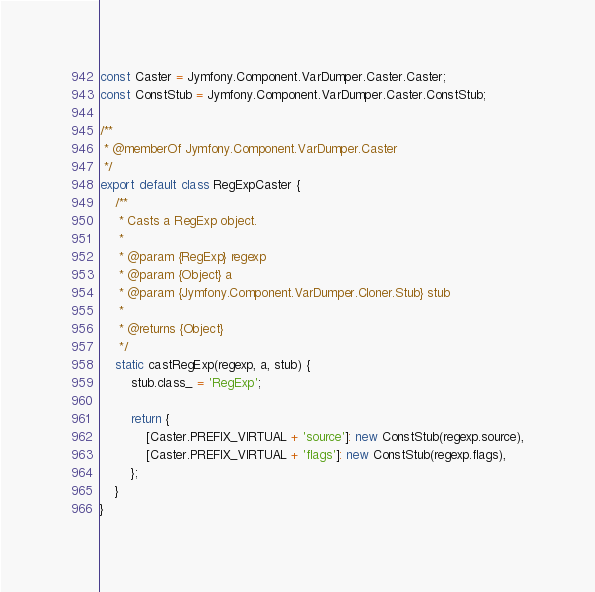Convert code to text. <code><loc_0><loc_0><loc_500><loc_500><_JavaScript_>const Caster = Jymfony.Component.VarDumper.Caster.Caster;
const ConstStub = Jymfony.Component.VarDumper.Caster.ConstStub;

/**
 * @memberOf Jymfony.Component.VarDumper.Caster
 */
export default class RegExpCaster {
    /**
     * Casts a RegExp object.
     *
     * @param {RegExp} regexp
     * @param {Object} a
     * @param {Jymfony.Component.VarDumper.Cloner.Stub} stub
     *
     * @returns {Object}
     */
    static castRegExp(regexp, a, stub) {
        stub.class_ = 'RegExp';

        return {
            [Caster.PREFIX_VIRTUAL + 'source']: new ConstStub(regexp.source),
            [Caster.PREFIX_VIRTUAL + 'flags']: new ConstStub(regexp.flags),
        };
    }
}
</code> 